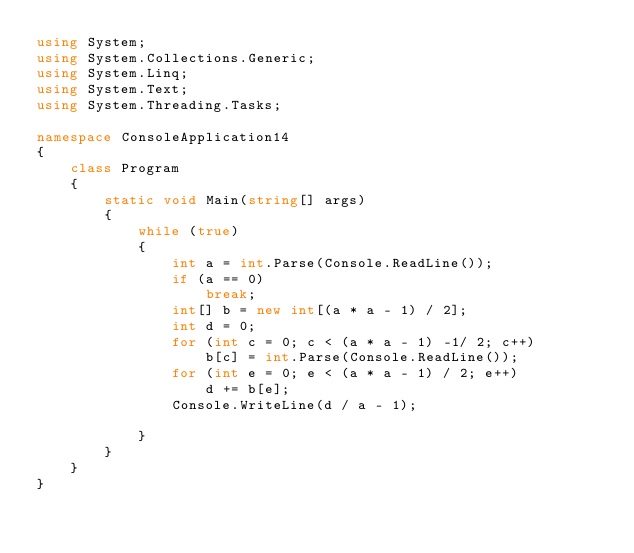<code> <loc_0><loc_0><loc_500><loc_500><_C#_>using System;
using System.Collections.Generic;
using System.Linq;
using System.Text;
using System.Threading.Tasks;

namespace ConsoleApplication14
{
    class Program
    {
        static void Main(string[] args)
        {
            while (true)
            {
                int a = int.Parse(Console.ReadLine());
                if (a == 0)
                    break;
                int[] b = new int[(a * a - 1) / 2];
                int d = 0;
                for (int c = 0; c < (a * a - 1) -1/ 2; c++)
                    b[c] = int.Parse(Console.ReadLine());
                for (int e = 0; e < (a * a - 1) / 2; e++)
                    d += b[e];
                Console.WriteLine(d / a - 1);

            }
        }
    }
}</code> 